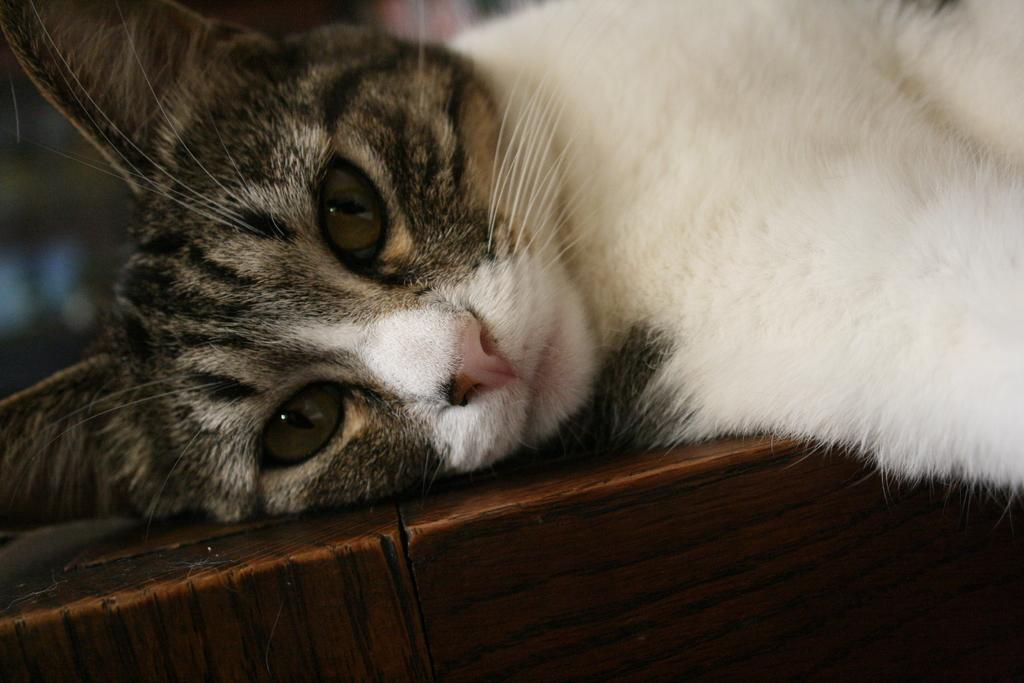What type of animal is present in the image? There is a cat in the image. What is the cat doing in the image? The cat is lying over a place. How many spiders are crawling on the cat's stomach in the image? There are no spiders present in the image, and the cat's stomach is not visible. What type of cup is the cat holding in the image? There is no cup present in the image; the cat is simply lying over a place. 